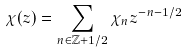Convert formula to latex. <formula><loc_0><loc_0><loc_500><loc_500>\chi ( z ) = \sum _ { n \in \mathbb { Z } + 1 / 2 } \chi _ { n } z ^ { - n - 1 / 2 }</formula> 